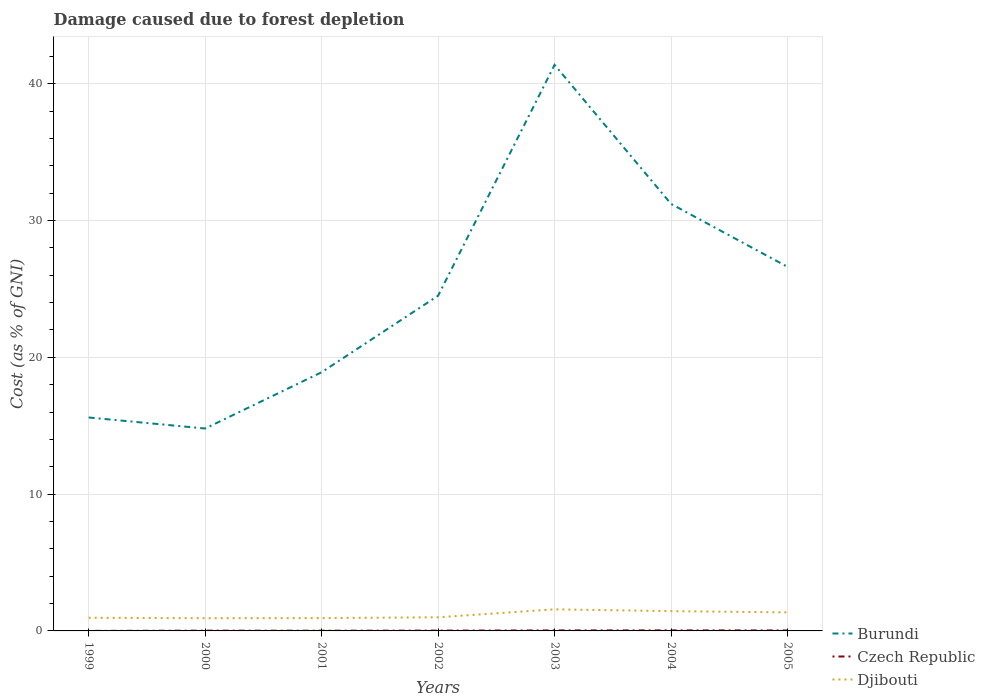How many different coloured lines are there?
Provide a short and direct response. 3. Across all years, what is the maximum cost of damage caused due to forest depletion in Djibouti?
Keep it short and to the point. 0.93. In which year was the cost of damage caused due to forest depletion in Djibouti maximum?
Your answer should be compact. 2000. What is the total cost of damage caused due to forest depletion in Djibouti in the graph?
Keep it short and to the point. -0.51. What is the difference between the highest and the second highest cost of damage caused due to forest depletion in Czech Republic?
Keep it short and to the point. 0.04. Does the graph contain any zero values?
Your answer should be very brief. No. Where does the legend appear in the graph?
Provide a short and direct response. Bottom right. How many legend labels are there?
Provide a succinct answer. 3. How are the legend labels stacked?
Make the answer very short. Vertical. What is the title of the graph?
Provide a succinct answer. Damage caused due to forest depletion. Does "Madagascar" appear as one of the legend labels in the graph?
Keep it short and to the point. No. What is the label or title of the X-axis?
Give a very brief answer. Years. What is the label or title of the Y-axis?
Ensure brevity in your answer.  Cost (as % of GNI). What is the Cost (as % of GNI) of Burundi in 1999?
Your answer should be very brief. 15.6. What is the Cost (as % of GNI) in Czech Republic in 1999?
Make the answer very short. 0. What is the Cost (as % of GNI) of Djibouti in 1999?
Give a very brief answer. 0.96. What is the Cost (as % of GNI) in Burundi in 2000?
Provide a short and direct response. 14.8. What is the Cost (as % of GNI) in Czech Republic in 2000?
Your answer should be compact. 0.02. What is the Cost (as % of GNI) in Djibouti in 2000?
Your response must be concise. 0.93. What is the Cost (as % of GNI) of Burundi in 2001?
Your answer should be very brief. 18.91. What is the Cost (as % of GNI) of Czech Republic in 2001?
Provide a succinct answer. 0.01. What is the Cost (as % of GNI) of Djibouti in 2001?
Your response must be concise. 0.94. What is the Cost (as % of GNI) of Burundi in 2002?
Provide a succinct answer. 24.5. What is the Cost (as % of GNI) of Czech Republic in 2002?
Provide a succinct answer. 0.02. What is the Cost (as % of GNI) of Djibouti in 2002?
Ensure brevity in your answer.  1. What is the Cost (as % of GNI) of Burundi in 2003?
Make the answer very short. 41.38. What is the Cost (as % of GNI) of Czech Republic in 2003?
Provide a succinct answer. 0.04. What is the Cost (as % of GNI) of Djibouti in 2003?
Give a very brief answer. 1.58. What is the Cost (as % of GNI) in Burundi in 2004?
Offer a terse response. 31.22. What is the Cost (as % of GNI) in Czech Republic in 2004?
Ensure brevity in your answer.  0.04. What is the Cost (as % of GNI) in Djibouti in 2004?
Give a very brief answer. 1.45. What is the Cost (as % of GNI) in Burundi in 2005?
Offer a very short reply. 26.61. What is the Cost (as % of GNI) of Czech Republic in 2005?
Your answer should be compact. 0.03. What is the Cost (as % of GNI) of Djibouti in 2005?
Your answer should be compact. 1.35. Across all years, what is the maximum Cost (as % of GNI) of Burundi?
Your answer should be compact. 41.38. Across all years, what is the maximum Cost (as % of GNI) in Czech Republic?
Ensure brevity in your answer.  0.04. Across all years, what is the maximum Cost (as % of GNI) in Djibouti?
Give a very brief answer. 1.58. Across all years, what is the minimum Cost (as % of GNI) in Burundi?
Your answer should be very brief. 14.8. Across all years, what is the minimum Cost (as % of GNI) of Czech Republic?
Your answer should be compact. 0. Across all years, what is the minimum Cost (as % of GNI) of Djibouti?
Give a very brief answer. 0.93. What is the total Cost (as % of GNI) in Burundi in the graph?
Keep it short and to the point. 173.02. What is the total Cost (as % of GNI) in Czech Republic in the graph?
Give a very brief answer. 0.17. What is the total Cost (as % of GNI) of Djibouti in the graph?
Make the answer very short. 8.21. What is the difference between the Cost (as % of GNI) of Burundi in 1999 and that in 2000?
Make the answer very short. 0.81. What is the difference between the Cost (as % of GNI) of Czech Republic in 1999 and that in 2000?
Keep it short and to the point. -0.02. What is the difference between the Cost (as % of GNI) in Djibouti in 1999 and that in 2000?
Make the answer very short. 0.03. What is the difference between the Cost (as % of GNI) in Burundi in 1999 and that in 2001?
Provide a short and direct response. -3.31. What is the difference between the Cost (as % of GNI) of Czech Republic in 1999 and that in 2001?
Keep it short and to the point. -0.01. What is the difference between the Cost (as % of GNI) in Djibouti in 1999 and that in 2001?
Keep it short and to the point. 0.02. What is the difference between the Cost (as % of GNI) in Burundi in 1999 and that in 2002?
Ensure brevity in your answer.  -8.9. What is the difference between the Cost (as % of GNI) of Czech Republic in 1999 and that in 2002?
Make the answer very short. -0.02. What is the difference between the Cost (as % of GNI) in Djibouti in 1999 and that in 2002?
Provide a short and direct response. -0.03. What is the difference between the Cost (as % of GNI) of Burundi in 1999 and that in 2003?
Provide a succinct answer. -25.78. What is the difference between the Cost (as % of GNI) of Czech Republic in 1999 and that in 2003?
Keep it short and to the point. -0.03. What is the difference between the Cost (as % of GNI) in Djibouti in 1999 and that in 2003?
Offer a terse response. -0.62. What is the difference between the Cost (as % of GNI) in Burundi in 1999 and that in 2004?
Your response must be concise. -15.61. What is the difference between the Cost (as % of GNI) of Czech Republic in 1999 and that in 2004?
Provide a succinct answer. -0.04. What is the difference between the Cost (as % of GNI) in Djibouti in 1999 and that in 2004?
Your response must be concise. -0.49. What is the difference between the Cost (as % of GNI) of Burundi in 1999 and that in 2005?
Make the answer very short. -11.01. What is the difference between the Cost (as % of GNI) of Czech Republic in 1999 and that in 2005?
Provide a short and direct response. -0.03. What is the difference between the Cost (as % of GNI) in Djibouti in 1999 and that in 2005?
Your response must be concise. -0.39. What is the difference between the Cost (as % of GNI) in Burundi in 2000 and that in 2001?
Your response must be concise. -4.11. What is the difference between the Cost (as % of GNI) in Czech Republic in 2000 and that in 2001?
Your answer should be compact. 0. What is the difference between the Cost (as % of GNI) of Djibouti in 2000 and that in 2001?
Make the answer very short. -0.01. What is the difference between the Cost (as % of GNI) of Burundi in 2000 and that in 2002?
Your response must be concise. -9.71. What is the difference between the Cost (as % of GNI) of Czech Republic in 2000 and that in 2002?
Provide a succinct answer. -0. What is the difference between the Cost (as % of GNI) in Djibouti in 2000 and that in 2002?
Your answer should be very brief. -0.07. What is the difference between the Cost (as % of GNI) in Burundi in 2000 and that in 2003?
Your response must be concise. -26.58. What is the difference between the Cost (as % of GNI) of Czech Republic in 2000 and that in 2003?
Your answer should be very brief. -0.02. What is the difference between the Cost (as % of GNI) in Djibouti in 2000 and that in 2003?
Offer a very short reply. -0.65. What is the difference between the Cost (as % of GNI) of Burundi in 2000 and that in 2004?
Your answer should be compact. -16.42. What is the difference between the Cost (as % of GNI) of Czech Republic in 2000 and that in 2004?
Your answer should be compact. -0.02. What is the difference between the Cost (as % of GNI) in Djibouti in 2000 and that in 2004?
Give a very brief answer. -0.52. What is the difference between the Cost (as % of GNI) of Burundi in 2000 and that in 2005?
Offer a very short reply. -11.82. What is the difference between the Cost (as % of GNI) in Czech Republic in 2000 and that in 2005?
Your answer should be very brief. -0.02. What is the difference between the Cost (as % of GNI) in Djibouti in 2000 and that in 2005?
Provide a succinct answer. -0.42. What is the difference between the Cost (as % of GNI) in Burundi in 2001 and that in 2002?
Provide a succinct answer. -5.59. What is the difference between the Cost (as % of GNI) of Czech Republic in 2001 and that in 2002?
Offer a very short reply. -0.01. What is the difference between the Cost (as % of GNI) in Djibouti in 2001 and that in 2002?
Your response must be concise. -0.06. What is the difference between the Cost (as % of GNI) of Burundi in 2001 and that in 2003?
Offer a terse response. -22.47. What is the difference between the Cost (as % of GNI) of Czech Republic in 2001 and that in 2003?
Make the answer very short. -0.02. What is the difference between the Cost (as % of GNI) in Djibouti in 2001 and that in 2003?
Offer a very short reply. -0.64. What is the difference between the Cost (as % of GNI) in Burundi in 2001 and that in 2004?
Offer a very short reply. -12.31. What is the difference between the Cost (as % of GNI) in Czech Republic in 2001 and that in 2004?
Provide a succinct answer. -0.02. What is the difference between the Cost (as % of GNI) of Djibouti in 2001 and that in 2004?
Your response must be concise. -0.51. What is the difference between the Cost (as % of GNI) of Burundi in 2001 and that in 2005?
Your answer should be very brief. -7.7. What is the difference between the Cost (as % of GNI) of Czech Republic in 2001 and that in 2005?
Your answer should be compact. -0.02. What is the difference between the Cost (as % of GNI) in Djibouti in 2001 and that in 2005?
Provide a short and direct response. -0.41. What is the difference between the Cost (as % of GNI) of Burundi in 2002 and that in 2003?
Make the answer very short. -16.88. What is the difference between the Cost (as % of GNI) in Czech Republic in 2002 and that in 2003?
Provide a succinct answer. -0.01. What is the difference between the Cost (as % of GNI) of Djibouti in 2002 and that in 2003?
Keep it short and to the point. -0.58. What is the difference between the Cost (as % of GNI) in Burundi in 2002 and that in 2004?
Your response must be concise. -6.71. What is the difference between the Cost (as % of GNI) in Czech Republic in 2002 and that in 2004?
Your response must be concise. -0.02. What is the difference between the Cost (as % of GNI) of Djibouti in 2002 and that in 2004?
Give a very brief answer. -0.45. What is the difference between the Cost (as % of GNI) of Burundi in 2002 and that in 2005?
Your response must be concise. -2.11. What is the difference between the Cost (as % of GNI) in Czech Republic in 2002 and that in 2005?
Your response must be concise. -0.01. What is the difference between the Cost (as % of GNI) in Djibouti in 2002 and that in 2005?
Make the answer very short. -0.36. What is the difference between the Cost (as % of GNI) in Burundi in 2003 and that in 2004?
Offer a very short reply. 10.16. What is the difference between the Cost (as % of GNI) in Czech Republic in 2003 and that in 2004?
Ensure brevity in your answer.  -0. What is the difference between the Cost (as % of GNI) of Djibouti in 2003 and that in 2004?
Your answer should be very brief. 0.13. What is the difference between the Cost (as % of GNI) in Burundi in 2003 and that in 2005?
Your response must be concise. 14.77. What is the difference between the Cost (as % of GNI) in Czech Republic in 2003 and that in 2005?
Your answer should be compact. 0. What is the difference between the Cost (as % of GNI) of Djibouti in 2003 and that in 2005?
Offer a very short reply. 0.22. What is the difference between the Cost (as % of GNI) of Burundi in 2004 and that in 2005?
Make the answer very short. 4.6. What is the difference between the Cost (as % of GNI) in Czech Republic in 2004 and that in 2005?
Your answer should be compact. 0. What is the difference between the Cost (as % of GNI) of Djibouti in 2004 and that in 2005?
Provide a short and direct response. 0.09. What is the difference between the Cost (as % of GNI) of Burundi in 1999 and the Cost (as % of GNI) of Czech Republic in 2000?
Offer a terse response. 15.58. What is the difference between the Cost (as % of GNI) of Burundi in 1999 and the Cost (as % of GNI) of Djibouti in 2000?
Make the answer very short. 14.67. What is the difference between the Cost (as % of GNI) of Czech Republic in 1999 and the Cost (as % of GNI) of Djibouti in 2000?
Give a very brief answer. -0.93. What is the difference between the Cost (as % of GNI) in Burundi in 1999 and the Cost (as % of GNI) in Czech Republic in 2001?
Offer a very short reply. 15.59. What is the difference between the Cost (as % of GNI) in Burundi in 1999 and the Cost (as % of GNI) in Djibouti in 2001?
Your answer should be very brief. 14.66. What is the difference between the Cost (as % of GNI) in Czech Republic in 1999 and the Cost (as % of GNI) in Djibouti in 2001?
Make the answer very short. -0.94. What is the difference between the Cost (as % of GNI) of Burundi in 1999 and the Cost (as % of GNI) of Czech Republic in 2002?
Ensure brevity in your answer.  15.58. What is the difference between the Cost (as % of GNI) in Burundi in 1999 and the Cost (as % of GNI) in Djibouti in 2002?
Provide a short and direct response. 14.61. What is the difference between the Cost (as % of GNI) of Czech Republic in 1999 and the Cost (as % of GNI) of Djibouti in 2002?
Offer a very short reply. -0.99. What is the difference between the Cost (as % of GNI) of Burundi in 1999 and the Cost (as % of GNI) of Czech Republic in 2003?
Give a very brief answer. 15.57. What is the difference between the Cost (as % of GNI) in Burundi in 1999 and the Cost (as % of GNI) in Djibouti in 2003?
Your answer should be very brief. 14.02. What is the difference between the Cost (as % of GNI) in Czech Republic in 1999 and the Cost (as % of GNI) in Djibouti in 2003?
Provide a short and direct response. -1.58. What is the difference between the Cost (as % of GNI) of Burundi in 1999 and the Cost (as % of GNI) of Czech Republic in 2004?
Offer a terse response. 15.56. What is the difference between the Cost (as % of GNI) in Burundi in 1999 and the Cost (as % of GNI) in Djibouti in 2004?
Make the answer very short. 14.16. What is the difference between the Cost (as % of GNI) in Czech Republic in 1999 and the Cost (as % of GNI) in Djibouti in 2004?
Give a very brief answer. -1.44. What is the difference between the Cost (as % of GNI) in Burundi in 1999 and the Cost (as % of GNI) in Czech Republic in 2005?
Provide a short and direct response. 15.57. What is the difference between the Cost (as % of GNI) in Burundi in 1999 and the Cost (as % of GNI) in Djibouti in 2005?
Keep it short and to the point. 14.25. What is the difference between the Cost (as % of GNI) in Czech Republic in 1999 and the Cost (as % of GNI) in Djibouti in 2005?
Offer a terse response. -1.35. What is the difference between the Cost (as % of GNI) of Burundi in 2000 and the Cost (as % of GNI) of Czech Republic in 2001?
Your answer should be very brief. 14.78. What is the difference between the Cost (as % of GNI) in Burundi in 2000 and the Cost (as % of GNI) in Djibouti in 2001?
Make the answer very short. 13.86. What is the difference between the Cost (as % of GNI) in Czech Republic in 2000 and the Cost (as % of GNI) in Djibouti in 2001?
Your answer should be very brief. -0.92. What is the difference between the Cost (as % of GNI) of Burundi in 2000 and the Cost (as % of GNI) of Czech Republic in 2002?
Offer a very short reply. 14.77. What is the difference between the Cost (as % of GNI) of Burundi in 2000 and the Cost (as % of GNI) of Djibouti in 2002?
Give a very brief answer. 13.8. What is the difference between the Cost (as % of GNI) in Czech Republic in 2000 and the Cost (as % of GNI) in Djibouti in 2002?
Offer a very short reply. -0.98. What is the difference between the Cost (as % of GNI) of Burundi in 2000 and the Cost (as % of GNI) of Czech Republic in 2003?
Your response must be concise. 14.76. What is the difference between the Cost (as % of GNI) in Burundi in 2000 and the Cost (as % of GNI) in Djibouti in 2003?
Make the answer very short. 13.22. What is the difference between the Cost (as % of GNI) of Czech Republic in 2000 and the Cost (as % of GNI) of Djibouti in 2003?
Offer a very short reply. -1.56. What is the difference between the Cost (as % of GNI) in Burundi in 2000 and the Cost (as % of GNI) in Czech Republic in 2004?
Your response must be concise. 14.76. What is the difference between the Cost (as % of GNI) in Burundi in 2000 and the Cost (as % of GNI) in Djibouti in 2004?
Provide a succinct answer. 13.35. What is the difference between the Cost (as % of GNI) of Czech Republic in 2000 and the Cost (as % of GNI) of Djibouti in 2004?
Offer a terse response. -1.43. What is the difference between the Cost (as % of GNI) in Burundi in 2000 and the Cost (as % of GNI) in Czech Republic in 2005?
Provide a short and direct response. 14.76. What is the difference between the Cost (as % of GNI) in Burundi in 2000 and the Cost (as % of GNI) in Djibouti in 2005?
Your answer should be compact. 13.44. What is the difference between the Cost (as % of GNI) in Czech Republic in 2000 and the Cost (as % of GNI) in Djibouti in 2005?
Your answer should be very brief. -1.33. What is the difference between the Cost (as % of GNI) of Burundi in 2001 and the Cost (as % of GNI) of Czech Republic in 2002?
Your response must be concise. 18.89. What is the difference between the Cost (as % of GNI) in Burundi in 2001 and the Cost (as % of GNI) in Djibouti in 2002?
Make the answer very short. 17.91. What is the difference between the Cost (as % of GNI) of Czech Republic in 2001 and the Cost (as % of GNI) of Djibouti in 2002?
Provide a succinct answer. -0.98. What is the difference between the Cost (as % of GNI) in Burundi in 2001 and the Cost (as % of GNI) in Czech Republic in 2003?
Offer a very short reply. 18.87. What is the difference between the Cost (as % of GNI) of Burundi in 2001 and the Cost (as % of GNI) of Djibouti in 2003?
Provide a succinct answer. 17.33. What is the difference between the Cost (as % of GNI) in Czech Republic in 2001 and the Cost (as % of GNI) in Djibouti in 2003?
Your answer should be very brief. -1.56. What is the difference between the Cost (as % of GNI) of Burundi in 2001 and the Cost (as % of GNI) of Czech Republic in 2004?
Provide a short and direct response. 18.87. What is the difference between the Cost (as % of GNI) in Burundi in 2001 and the Cost (as % of GNI) in Djibouti in 2004?
Keep it short and to the point. 17.46. What is the difference between the Cost (as % of GNI) in Czech Republic in 2001 and the Cost (as % of GNI) in Djibouti in 2004?
Make the answer very short. -1.43. What is the difference between the Cost (as % of GNI) in Burundi in 2001 and the Cost (as % of GNI) in Czech Republic in 2005?
Provide a short and direct response. 18.88. What is the difference between the Cost (as % of GNI) in Burundi in 2001 and the Cost (as % of GNI) in Djibouti in 2005?
Your answer should be very brief. 17.56. What is the difference between the Cost (as % of GNI) of Czech Republic in 2001 and the Cost (as % of GNI) of Djibouti in 2005?
Give a very brief answer. -1.34. What is the difference between the Cost (as % of GNI) of Burundi in 2002 and the Cost (as % of GNI) of Czech Republic in 2003?
Your answer should be compact. 24.47. What is the difference between the Cost (as % of GNI) in Burundi in 2002 and the Cost (as % of GNI) in Djibouti in 2003?
Offer a very short reply. 22.93. What is the difference between the Cost (as % of GNI) of Czech Republic in 2002 and the Cost (as % of GNI) of Djibouti in 2003?
Give a very brief answer. -1.55. What is the difference between the Cost (as % of GNI) in Burundi in 2002 and the Cost (as % of GNI) in Czech Republic in 2004?
Keep it short and to the point. 24.46. What is the difference between the Cost (as % of GNI) of Burundi in 2002 and the Cost (as % of GNI) of Djibouti in 2004?
Ensure brevity in your answer.  23.06. What is the difference between the Cost (as % of GNI) in Czech Republic in 2002 and the Cost (as % of GNI) in Djibouti in 2004?
Give a very brief answer. -1.42. What is the difference between the Cost (as % of GNI) in Burundi in 2002 and the Cost (as % of GNI) in Czech Republic in 2005?
Keep it short and to the point. 24.47. What is the difference between the Cost (as % of GNI) in Burundi in 2002 and the Cost (as % of GNI) in Djibouti in 2005?
Give a very brief answer. 23.15. What is the difference between the Cost (as % of GNI) in Czech Republic in 2002 and the Cost (as % of GNI) in Djibouti in 2005?
Your response must be concise. -1.33. What is the difference between the Cost (as % of GNI) of Burundi in 2003 and the Cost (as % of GNI) of Czech Republic in 2004?
Give a very brief answer. 41.34. What is the difference between the Cost (as % of GNI) in Burundi in 2003 and the Cost (as % of GNI) in Djibouti in 2004?
Keep it short and to the point. 39.93. What is the difference between the Cost (as % of GNI) of Czech Republic in 2003 and the Cost (as % of GNI) of Djibouti in 2004?
Your answer should be compact. -1.41. What is the difference between the Cost (as % of GNI) of Burundi in 2003 and the Cost (as % of GNI) of Czech Republic in 2005?
Keep it short and to the point. 41.35. What is the difference between the Cost (as % of GNI) in Burundi in 2003 and the Cost (as % of GNI) in Djibouti in 2005?
Give a very brief answer. 40.03. What is the difference between the Cost (as % of GNI) of Czech Republic in 2003 and the Cost (as % of GNI) of Djibouti in 2005?
Your answer should be compact. -1.32. What is the difference between the Cost (as % of GNI) of Burundi in 2004 and the Cost (as % of GNI) of Czech Republic in 2005?
Keep it short and to the point. 31.18. What is the difference between the Cost (as % of GNI) in Burundi in 2004 and the Cost (as % of GNI) in Djibouti in 2005?
Provide a succinct answer. 29.86. What is the difference between the Cost (as % of GNI) of Czech Republic in 2004 and the Cost (as % of GNI) of Djibouti in 2005?
Your response must be concise. -1.31. What is the average Cost (as % of GNI) in Burundi per year?
Your answer should be compact. 24.72. What is the average Cost (as % of GNI) in Czech Republic per year?
Your answer should be very brief. 0.02. What is the average Cost (as % of GNI) in Djibouti per year?
Make the answer very short. 1.17. In the year 1999, what is the difference between the Cost (as % of GNI) in Burundi and Cost (as % of GNI) in Czech Republic?
Your response must be concise. 15.6. In the year 1999, what is the difference between the Cost (as % of GNI) of Burundi and Cost (as % of GNI) of Djibouti?
Keep it short and to the point. 14.64. In the year 1999, what is the difference between the Cost (as % of GNI) of Czech Republic and Cost (as % of GNI) of Djibouti?
Your response must be concise. -0.96. In the year 2000, what is the difference between the Cost (as % of GNI) in Burundi and Cost (as % of GNI) in Czech Republic?
Provide a short and direct response. 14.78. In the year 2000, what is the difference between the Cost (as % of GNI) in Burundi and Cost (as % of GNI) in Djibouti?
Provide a succinct answer. 13.87. In the year 2000, what is the difference between the Cost (as % of GNI) of Czech Republic and Cost (as % of GNI) of Djibouti?
Ensure brevity in your answer.  -0.91. In the year 2001, what is the difference between the Cost (as % of GNI) of Burundi and Cost (as % of GNI) of Czech Republic?
Your response must be concise. 18.89. In the year 2001, what is the difference between the Cost (as % of GNI) in Burundi and Cost (as % of GNI) in Djibouti?
Your response must be concise. 17.97. In the year 2001, what is the difference between the Cost (as % of GNI) of Czech Republic and Cost (as % of GNI) of Djibouti?
Your answer should be very brief. -0.92. In the year 2002, what is the difference between the Cost (as % of GNI) of Burundi and Cost (as % of GNI) of Czech Republic?
Ensure brevity in your answer.  24.48. In the year 2002, what is the difference between the Cost (as % of GNI) of Burundi and Cost (as % of GNI) of Djibouti?
Make the answer very short. 23.51. In the year 2002, what is the difference between the Cost (as % of GNI) in Czech Republic and Cost (as % of GNI) in Djibouti?
Ensure brevity in your answer.  -0.97. In the year 2003, what is the difference between the Cost (as % of GNI) in Burundi and Cost (as % of GNI) in Czech Republic?
Provide a succinct answer. 41.34. In the year 2003, what is the difference between the Cost (as % of GNI) of Burundi and Cost (as % of GNI) of Djibouti?
Offer a very short reply. 39.8. In the year 2003, what is the difference between the Cost (as % of GNI) in Czech Republic and Cost (as % of GNI) in Djibouti?
Provide a succinct answer. -1.54. In the year 2004, what is the difference between the Cost (as % of GNI) of Burundi and Cost (as % of GNI) of Czech Republic?
Your answer should be very brief. 31.18. In the year 2004, what is the difference between the Cost (as % of GNI) in Burundi and Cost (as % of GNI) in Djibouti?
Provide a short and direct response. 29.77. In the year 2004, what is the difference between the Cost (as % of GNI) in Czech Republic and Cost (as % of GNI) in Djibouti?
Your response must be concise. -1.41. In the year 2005, what is the difference between the Cost (as % of GNI) of Burundi and Cost (as % of GNI) of Czech Republic?
Give a very brief answer. 26.58. In the year 2005, what is the difference between the Cost (as % of GNI) of Burundi and Cost (as % of GNI) of Djibouti?
Offer a terse response. 25.26. In the year 2005, what is the difference between the Cost (as % of GNI) of Czech Republic and Cost (as % of GNI) of Djibouti?
Ensure brevity in your answer.  -1.32. What is the ratio of the Cost (as % of GNI) of Burundi in 1999 to that in 2000?
Keep it short and to the point. 1.05. What is the ratio of the Cost (as % of GNI) of Czech Republic in 1999 to that in 2000?
Provide a short and direct response. 0.12. What is the ratio of the Cost (as % of GNI) of Djibouti in 1999 to that in 2000?
Your response must be concise. 1.04. What is the ratio of the Cost (as % of GNI) of Burundi in 1999 to that in 2001?
Provide a short and direct response. 0.83. What is the ratio of the Cost (as % of GNI) in Czech Republic in 1999 to that in 2001?
Your answer should be compact. 0.16. What is the ratio of the Cost (as % of GNI) in Djibouti in 1999 to that in 2001?
Provide a short and direct response. 1.02. What is the ratio of the Cost (as % of GNI) of Burundi in 1999 to that in 2002?
Keep it short and to the point. 0.64. What is the ratio of the Cost (as % of GNI) in Czech Republic in 1999 to that in 2002?
Provide a short and direct response. 0.1. What is the ratio of the Cost (as % of GNI) in Djibouti in 1999 to that in 2002?
Provide a short and direct response. 0.97. What is the ratio of the Cost (as % of GNI) of Burundi in 1999 to that in 2003?
Keep it short and to the point. 0.38. What is the ratio of the Cost (as % of GNI) in Czech Republic in 1999 to that in 2003?
Provide a short and direct response. 0.07. What is the ratio of the Cost (as % of GNI) in Djibouti in 1999 to that in 2003?
Your answer should be very brief. 0.61. What is the ratio of the Cost (as % of GNI) in Burundi in 1999 to that in 2004?
Give a very brief answer. 0.5. What is the ratio of the Cost (as % of GNI) of Czech Republic in 1999 to that in 2004?
Your response must be concise. 0.06. What is the ratio of the Cost (as % of GNI) in Djibouti in 1999 to that in 2004?
Offer a terse response. 0.66. What is the ratio of the Cost (as % of GNI) in Burundi in 1999 to that in 2005?
Provide a short and direct response. 0.59. What is the ratio of the Cost (as % of GNI) in Czech Republic in 1999 to that in 2005?
Give a very brief answer. 0.07. What is the ratio of the Cost (as % of GNI) in Djibouti in 1999 to that in 2005?
Offer a terse response. 0.71. What is the ratio of the Cost (as % of GNI) in Burundi in 2000 to that in 2001?
Make the answer very short. 0.78. What is the ratio of the Cost (as % of GNI) of Czech Republic in 2000 to that in 2001?
Your response must be concise. 1.28. What is the ratio of the Cost (as % of GNI) in Burundi in 2000 to that in 2002?
Ensure brevity in your answer.  0.6. What is the ratio of the Cost (as % of GNI) of Czech Republic in 2000 to that in 2002?
Provide a short and direct response. 0.83. What is the ratio of the Cost (as % of GNI) in Djibouti in 2000 to that in 2002?
Make the answer very short. 0.93. What is the ratio of the Cost (as % of GNI) in Burundi in 2000 to that in 2003?
Make the answer very short. 0.36. What is the ratio of the Cost (as % of GNI) in Czech Republic in 2000 to that in 2003?
Ensure brevity in your answer.  0.53. What is the ratio of the Cost (as % of GNI) of Djibouti in 2000 to that in 2003?
Make the answer very short. 0.59. What is the ratio of the Cost (as % of GNI) in Burundi in 2000 to that in 2004?
Your answer should be very brief. 0.47. What is the ratio of the Cost (as % of GNI) of Czech Republic in 2000 to that in 2004?
Offer a terse response. 0.49. What is the ratio of the Cost (as % of GNI) of Djibouti in 2000 to that in 2004?
Your answer should be very brief. 0.64. What is the ratio of the Cost (as % of GNI) of Burundi in 2000 to that in 2005?
Keep it short and to the point. 0.56. What is the ratio of the Cost (as % of GNI) of Czech Republic in 2000 to that in 2005?
Your response must be concise. 0.56. What is the ratio of the Cost (as % of GNI) of Djibouti in 2000 to that in 2005?
Your answer should be very brief. 0.69. What is the ratio of the Cost (as % of GNI) of Burundi in 2001 to that in 2002?
Offer a very short reply. 0.77. What is the ratio of the Cost (as % of GNI) of Czech Republic in 2001 to that in 2002?
Provide a succinct answer. 0.64. What is the ratio of the Cost (as % of GNI) in Djibouti in 2001 to that in 2002?
Offer a terse response. 0.94. What is the ratio of the Cost (as % of GNI) in Burundi in 2001 to that in 2003?
Your response must be concise. 0.46. What is the ratio of the Cost (as % of GNI) of Czech Republic in 2001 to that in 2003?
Offer a very short reply. 0.41. What is the ratio of the Cost (as % of GNI) in Djibouti in 2001 to that in 2003?
Offer a very short reply. 0.59. What is the ratio of the Cost (as % of GNI) in Burundi in 2001 to that in 2004?
Ensure brevity in your answer.  0.61. What is the ratio of the Cost (as % of GNI) of Czech Republic in 2001 to that in 2004?
Make the answer very short. 0.38. What is the ratio of the Cost (as % of GNI) in Djibouti in 2001 to that in 2004?
Ensure brevity in your answer.  0.65. What is the ratio of the Cost (as % of GNI) in Burundi in 2001 to that in 2005?
Your answer should be very brief. 0.71. What is the ratio of the Cost (as % of GNI) in Czech Republic in 2001 to that in 2005?
Give a very brief answer. 0.44. What is the ratio of the Cost (as % of GNI) in Djibouti in 2001 to that in 2005?
Give a very brief answer. 0.69. What is the ratio of the Cost (as % of GNI) of Burundi in 2002 to that in 2003?
Ensure brevity in your answer.  0.59. What is the ratio of the Cost (as % of GNI) in Czech Republic in 2002 to that in 2003?
Provide a succinct answer. 0.64. What is the ratio of the Cost (as % of GNI) in Djibouti in 2002 to that in 2003?
Ensure brevity in your answer.  0.63. What is the ratio of the Cost (as % of GNI) in Burundi in 2002 to that in 2004?
Provide a short and direct response. 0.78. What is the ratio of the Cost (as % of GNI) of Czech Republic in 2002 to that in 2004?
Your response must be concise. 0.6. What is the ratio of the Cost (as % of GNI) of Djibouti in 2002 to that in 2004?
Give a very brief answer. 0.69. What is the ratio of the Cost (as % of GNI) in Burundi in 2002 to that in 2005?
Your answer should be compact. 0.92. What is the ratio of the Cost (as % of GNI) in Czech Republic in 2002 to that in 2005?
Provide a short and direct response. 0.68. What is the ratio of the Cost (as % of GNI) of Djibouti in 2002 to that in 2005?
Ensure brevity in your answer.  0.74. What is the ratio of the Cost (as % of GNI) of Burundi in 2003 to that in 2004?
Offer a terse response. 1.33. What is the ratio of the Cost (as % of GNI) of Czech Republic in 2003 to that in 2004?
Your response must be concise. 0.93. What is the ratio of the Cost (as % of GNI) of Djibouti in 2003 to that in 2004?
Provide a short and direct response. 1.09. What is the ratio of the Cost (as % of GNI) of Burundi in 2003 to that in 2005?
Offer a very short reply. 1.55. What is the ratio of the Cost (as % of GNI) in Czech Republic in 2003 to that in 2005?
Offer a very short reply. 1.05. What is the ratio of the Cost (as % of GNI) in Djibouti in 2003 to that in 2005?
Offer a terse response. 1.17. What is the ratio of the Cost (as % of GNI) in Burundi in 2004 to that in 2005?
Give a very brief answer. 1.17. What is the ratio of the Cost (as % of GNI) of Czech Republic in 2004 to that in 2005?
Your answer should be very brief. 1.14. What is the ratio of the Cost (as % of GNI) of Djibouti in 2004 to that in 2005?
Ensure brevity in your answer.  1.07. What is the difference between the highest and the second highest Cost (as % of GNI) of Burundi?
Keep it short and to the point. 10.16. What is the difference between the highest and the second highest Cost (as % of GNI) of Czech Republic?
Your answer should be compact. 0. What is the difference between the highest and the second highest Cost (as % of GNI) in Djibouti?
Ensure brevity in your answer.  0.13. What is the difference between the highest and the lowest Cost (as % of GNI) in Burundi?
Make the answer very short. 26.58. What is the difference between the highest and the lowest Cost (as % of GNI) in Czech Republic?
Offer a terse response. 0.04. What is the difference between the highest and the lowest Cost (as % of GNI) of Djibouti?
Your answer should be compact. 0.65. 